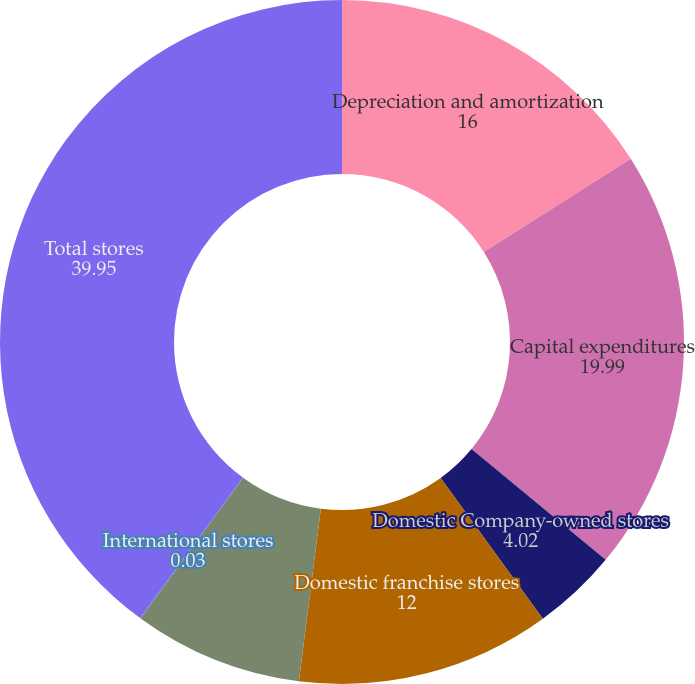Convert chart. <chart><loc_0><loc_0><loc_500><loc_500><pie_chart><fcel>Depreciation and amortization<fcel>Capital expenditures<fcel>Domestic Company-owned stores<fcel>Domestic franchise stores<fcel>Domestic stores<fcel>International stores<fcel>Total stores<nl><fcel>16.0%<fcel>19.99%<fcel>4.02%<fcel>12.0%<fcel>8.01%<fcel>0.03%<fcel>39.95%<nl></chart> 